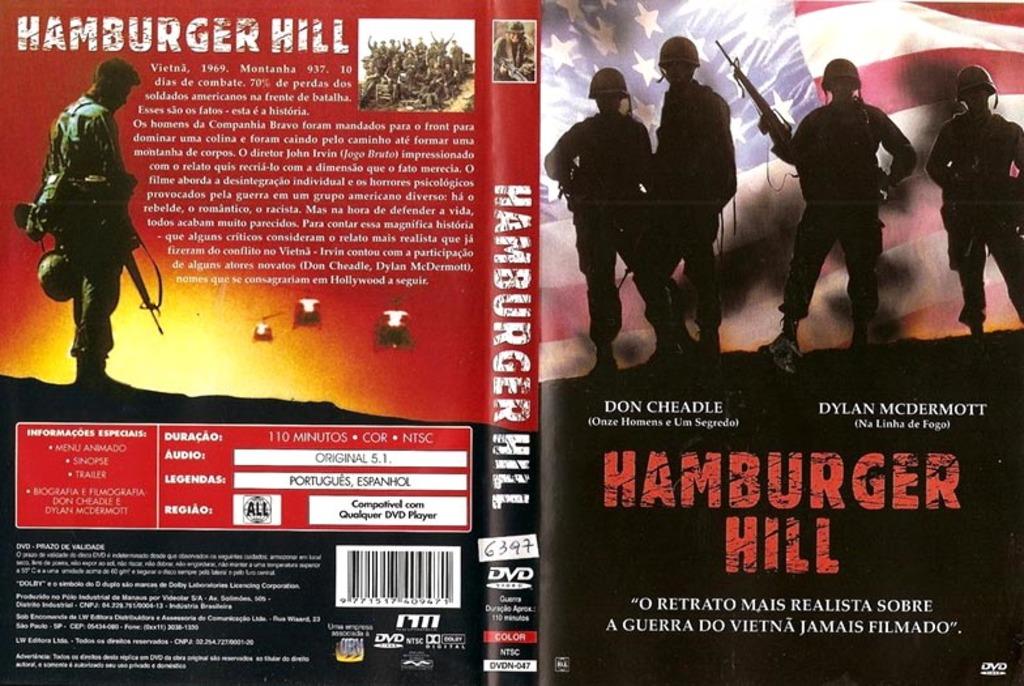What is the name of the book?
Provide a short and direct response. Hamburger hill. How long is this movie?
Your answer should be very brief. 110 minutes. 